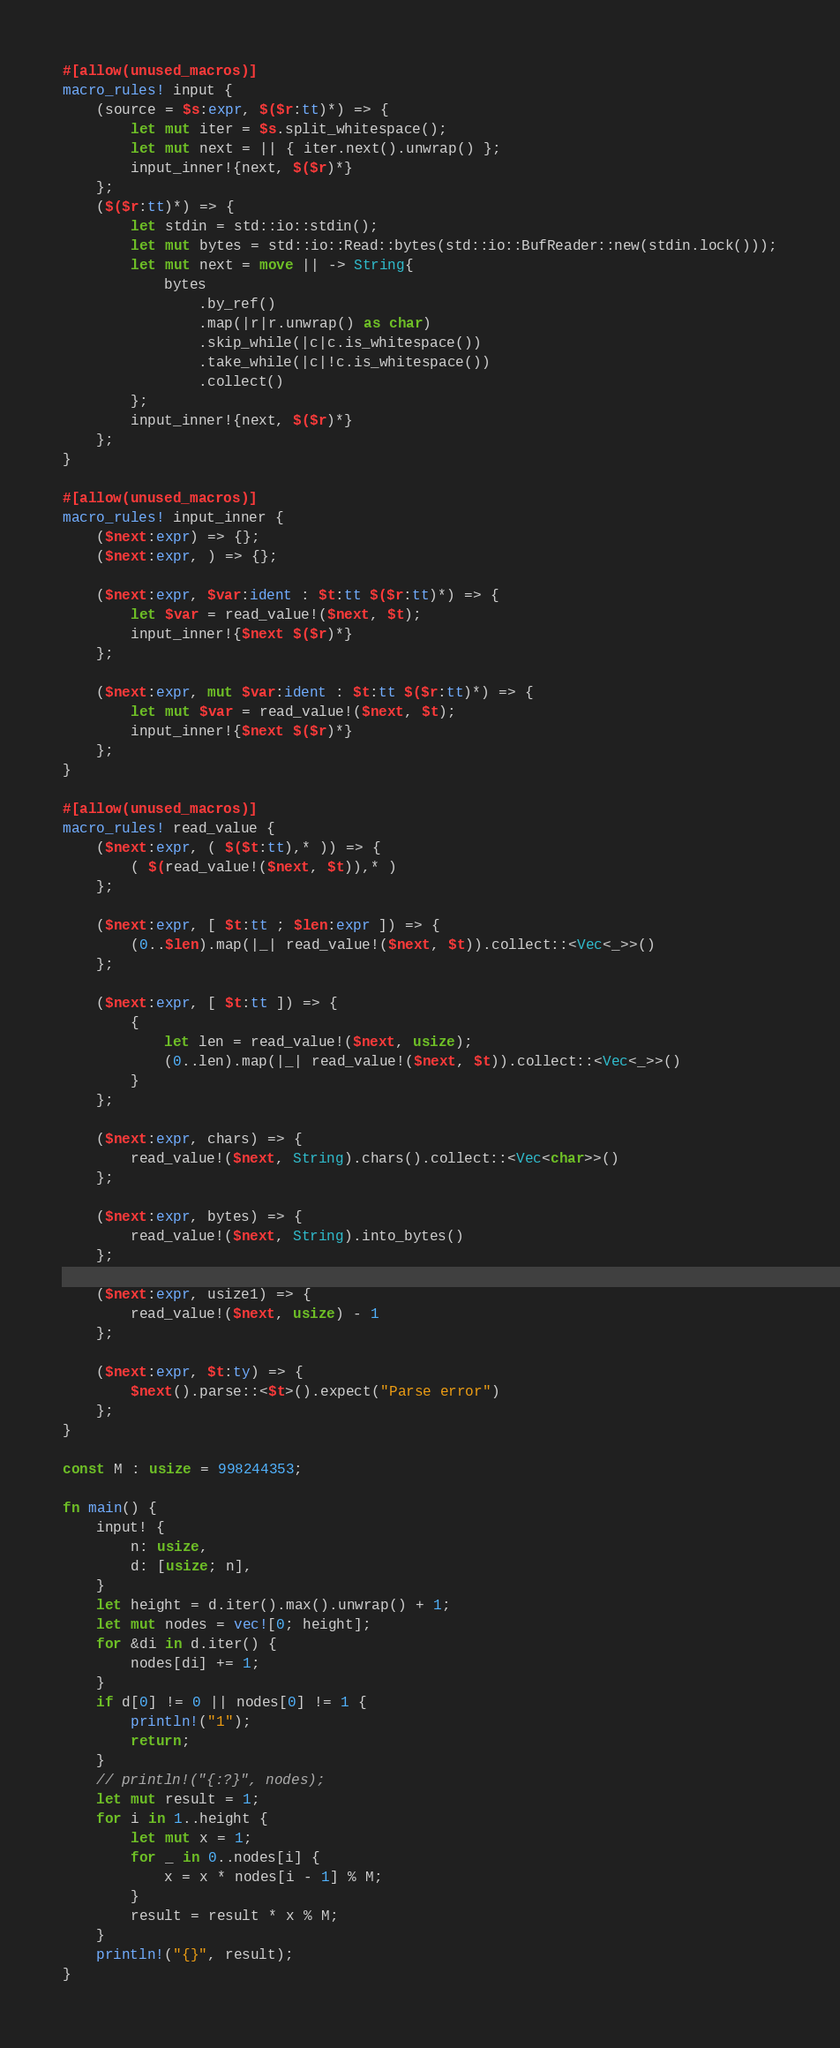Convert code to text. <code><loc_0><loc_0><loc_500><loc_500><_Rust_>#[allow(unused_macros)]
macro_rules! input {
    (source = $s:expr, $($r:tt)*) => {
        let mut iter = $s.split_whitespace();
        let mut next = || { iter.next().unwrap() };
        input_inner!{next, $($r)*}
    };
    ($($r:tt)*) => {
        let stdin = std::io::stdin();
        let mut bytes = std::io::Read::bytes(std::io::BufReader::new(stdin.lock()));
        let mut next = move || -> String{
            bytes
                .by_ref()
                .map(|r|r.unwrap() as char)
                .skip_while(|c|c.is_whitespace())
                .take_while(|c|!c.is_whitespace())
                .collect()
        };
        input_inner!{next, $($r)*}
    };
}

#[allow(unused_macros)]
macro_rules! input_inner {
    ($next:expr) => {};
    ($next:expr, ) => {};

    ($next:expr, $var:ident : $t:tt $($r:tt)*) => {
        let $var = read_value!($next, $t);
        input_inner!{$next $($r)*}
    };

    ($next:expr, mut $var:ident : $t:tt $($r:tt)*) => {
        let mut $var = read_value!($next, $t);
        input_inner!{$next $($r)*}
    };
}

#[allow(unused_macros)]
macro_rules! read_value {
    ($next:expr, ( $($t:tt),* )) => {
        ( $(read_value!($next, $t)),* )
    };

    ($next:expr, [ $t:tt ; $len:expr ]) => {
        (0..$len).map(|_| read_value!($next, $t)).collect::<Vec<_>>()
    };

    ($next:expr, [ $t:tt ]) => {
        {
            let len = read_value!($next, usize);
            (0..len).map(|_| read_value!($next, $t)).collect::<Vec<_>>()
        }
    };

    ($next:expr, chars) => {
        read_value!($next, String).chars().collect::<Vec<char>>()
    };

    ($next:expr, bytes) => {
        read_value!($next, String).into_bytes()
    };

    ($next:expr, usize1) => {
        read_value!($next, usize) - 1
    };

    ($next:expr, $t:ty) => {
        $next().parse::<$t>().expect("Parse error")
    };
}

const M : usize = 998244353;

fn main() {
    input! {
        n: usize,
        d: [usize; n],
    }
    let height = d.iter().max().unwrap() + 1;
    let mut nodes = vec![0; height];
    for &di in d.iter() {
        nodes[di] += 1;
    }
    if d[0] != 0 || nodes[0] != 1 {
        println!("1");
        return;
    }
    // println!("{:?}", nodes);
    let mut result = 1;
    for i in 1..height {
        let mut x = 1;
        for _ in 0..nodes[i] {
            x = x * nodes[i - 1] % M;
        }
        result = result * x % M;
    }
    println!("{}", result);
}
</code> 